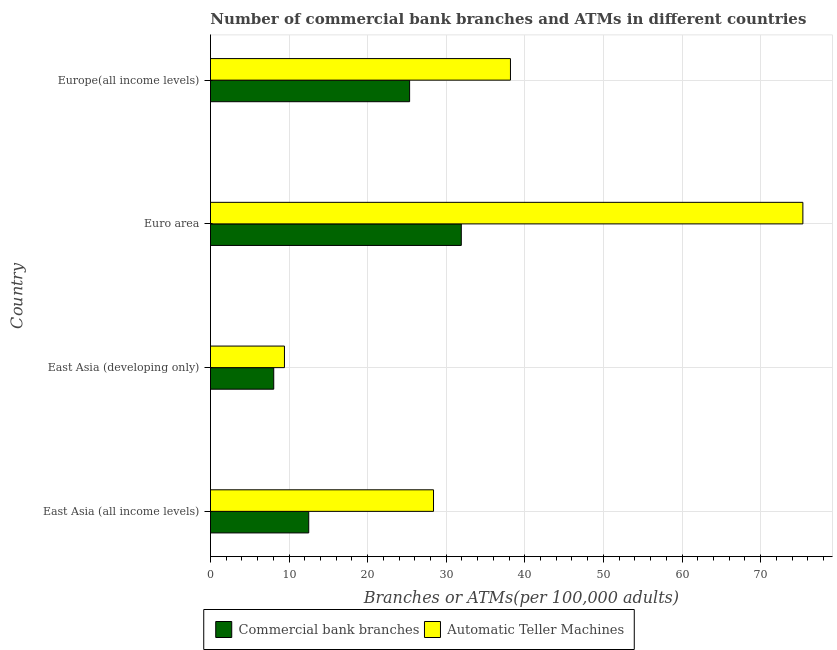Are the number of bars per tick equal to the number of legend labels?
Offer a very short reply. Yes. How many bars are there on the 2nd tick from the top?
Provide a succinct answer. 2. What is the label of the 4th group of bars from the top?
Give a very brief answer. East Asia (all income levels). In how many cases, is the number of bars for a given country not equal to the number of legend labels?
Provide a succinct answer. 0. What is the number of atms in Euro area?
Offer a very short reply. 75.38. Across all countries, what is the maximum number of commercal bank branches?
Provide a short and direct response. 31.92. Across all countries, what is the minimum number of atms?
Provide a short and direct response. 9.41. In which country was the number of commercal bank branches minimum?
Give a very brief answer. East Asia (developing only). What is the total number of commercal bank branches in the graph?
Provide a short and direct response. 77.81. What is the difference between the number of atms in East Asia (all income levels) and that in Euro area?
Provide a succinct answer. -47. What is the difference between the number of commercal bank branches in Europe(all income levels) and the number of atms in East Asia (developing only)?
Offer a very short reply. 15.92. What is the average number of commercal bank branches per country?
Provide a short and direct response. 19.45. What is the difference between the number of commercal bank branches and number of atms in East Asia (all income levels)?
Offer a very short reply. -15.88. What is the ratio of the number of commercal bank branches in East Asia (all income levels) to that in Euro area?
Offer a very short reply. 0.39. Is the difference between the number of atms in East Asia (all income levels) and Europe(all income levels) greater than the difference between the number of commercal bank branches in East Asia (all income levels) and Europe(all income levels)?
Provide a succinct answer. Yes. What is the difference between the highest and the second highest number of atms?
Make the answer very short. 37.21. What is the difference between the highest and the lowest number of atms?
Your answer should be compact. 65.96. Is the sum of the number of atms in East Asia (all income levels) and East Asia (developing only) greater than the maximum number of commercal bank branches across all countries?
Provide a short and direct response. Yes. What does the 2nd bar from the top in East Asia (developing only) represents?
Provide a short and direct response. Commercial bank branches. What does the 1st bar from the bottom in Euro area represents?
Provide a short and direct response. Commercial bank branches. How many bars are there?
Your answer should be very brief. 8. Are all the bars in the graph horizontal?
Ensure brevity in your answer.  Yes. How many countries are there in the graph?
Keep it short and to the point. 4. What is the difference between two consecutive major ticks on the X-axis?
Your answer should be very brief. 10. Where does the legend appear in the graph?
Give a very brief answer. Bottom center. What is the title of the graph?
Your response must be concise. Number of commercial bank branches and ATMs in different countries. Does "Methane" appear as one of the legend labels in the graph?
Keep it short and to the point. No. What is the label or title of the X-axis?
Provide a short and direct response. Branches or ATMs(per 100,0 adults). What is the Branches or ATMs(per 100,000 adults) of Commercial bank branches in East Asia (all income levels)?
Provide a succinct answer. 12.5. What is the Branches or ATMs(per 100,000 adults) in Automatic Teller Machines in East Asia (all income levels)?
Offer a very short reply. 28.38. What is the Branches or ATMs(per 100,000 adults) of Commercial bank branches in East Asia (developing only)?
Your response must be concise. 8.05. What is the Branches or ATMs(per 100,000 adults) in Automatic Teller Machines in East Asia (developing only)?
Keep it short and to the point. 9.41. What is the Branches or ATMs(per 100,000 adults) in Commercial bank branches in Euro area?
Offer a terse response. 31.92. What is the Branches or ATMs(per 100,000 adults) of Automatic Teller Machines in Euro area?
Your answer should be compact. 75.38. What is the Branches or ATMs(per 100,000 adults) of Commercial bank branches in Europe(all income levels)?
Provide a short and direct response. 25.34. What is the Branches or ATMs(per 100,000 adults) of Automatic Teller Machines in Europe(all income levels)?
Ensure brevity in your answer.  38.17. Across all countries, what is the maximum Branches or ATMs(per 100,000 adults) in Commercial bank branches?
Ensure brevity in your answer.  31.92. Across all countries, what is the maximum Branches or ATMs(per 100,000 adults) of Automatic Teller Machines?
Make the answer very short. 75.38. Across all countries, what is the minimum Branches or ATMs(per 100,000 adults) in Commercial bank branches?
Your answer should be very brief. 8.05. Across all countries, what is the minimum Branches or ATMs(per 100,000 adults) of Automatic Teller Machines?
Provide a succinct answer. 9.41. What is the total Branches or ATMs(per 100,000 adults) of Commercial bank branches in the graph?
Offer a very short reply. 77.81. What is the total Branches or ATMs(per 100,000 adults) of Automatic Teller Machines in the graph?
Ensure brevity in your answer.  151.34. What is the difference between the Branches or ATMs(per 100,000 adults) of Commercial bank branches in East Asia (all income levels) and that in East Asia (developing only)?
Provide a short and direct response. 4.45. What is the difference between the Branches or ATMs(per 100,000 adults) of Automatic Teller Machines in East Asia (all income levels) and that in East Asia (developing only)?
Your answer should be very brief. 18.97. What is the difference between the Branches or ATMs(per 100,000 adults) in Commercial bank branches in East Asia (all income levels) and that in Euro area?
Ensure brevity in your answer.  -19.41. What is the difference between the Branches or ATMs(per 100,000 adults) in Automatic Teller Machines in East Asia (all income levels) and that in Euro area?
Your answer should be compact. -47. What is the difference between the Branches or ATMs(per 100,000 adults) in Commercial bank branches in East Asia (all income levels) and that in Europe(all income levels)?
Ensure brevity in your answer.  -12.84. What is the difference between the Branches or ATMs(per 100,000 adults) of Automatic Teller Machines in East Asia (all income levels) and that in Europe(all income levels)?
Offer a very short reply. -9.79. What is the difference between the Branches or ATMs(per 100,000 adults) in Commercial bank branches in East Asia (developing only) and that in Euro area?
Keep it short and to the point. -23.87. What is the difference between the Branches or ATMs(per 100,000 adults) of Automatic Teller Machines in East Asia (developing only) and that in Euro area?
Give a very brief answer. -65.96. What is the difference between the Branches or ATMs(per 100,000 adults) of Commercial bank branches in East Asia (developing only) and that in Europe(all income levels)?
Your answer should be compact. -17.29. What is the difference between the Branches or ATMs(per 100,000 adults) in Automatic Teller Machines in East Asia (developing only) and that in Europe(all income levels)?
Provide a succinct answer. -28.76. What is the difference between the Branches or ATMs(per 100,000 adults) in Commercial bank branches in Euro area and that in Europe(all income levels)?
Ensure brevity in your answer.  6.58. What is the difference between the Branches or ATMs(per 100,000 adults) of Automatic Teller Machines in Euro area and that in Europe(all income levels)?
Provide a short and direct response. 37.21. What is the difference between the Branches or ATMs(per 100,000 adults) of Commercial bank branches in East Asia (all income levels) and the Branches or ATMs(per 100,000 adults) of Automatic Teller Machines in East Asia (developing only)?
Make the answer very short. 3.09. What is the difference between the Branches or ATMs(per 100,000 adults) in Commercial bank branches in East Asia (all income levels) and the Branches or ATMs(per 100,000 adults) in Automatic Teller Machines in Euro area?
Give a very brief answer. -62.88. What is the difference between the Branches or ATMs(per 100,000 adults) in Commercial bank branches in East Asia (all income levels) and the Branches or ATMs(per 100,000 adults) in Automatic Teller Machines in Europe(all income levels)?
Offer a very short reply. -25.67. What is the difference between the Branches or ATMs(per 100,000 adults) of Commercial bank branches in East Asia (developing only) and the Branches or ATMs(per 100,000 adults) of Automatic Teller Machines in Euro area?
Provide a short and direct response. -67.33. What is the difference between the Branches or ATMs(per 100,000 adults) in Commercial bank branches in East Asia (developing only) and the Branches or ATMs(per 100,000 adults) in Automatic Teller Machines in Europe(all income levels)?
Your answer should be very brief. -30.12. What is the difference between the Branches or ATMs(per 100,000 adults) of Commercial bank branches in Euro area and the Branches or ATMs(per 100,000 adults) of Automatic Teller Machines in Europe(all income levels)?
Offer a very short reply. -6.25. What is the average Branches or ATMs(per 100,000 adults) of Commercial bank branches per country?
Offer a very short reply. 19.45. What is the average Branches or ATMs(per 100,000 adults) of Automatic Teller Machines per country?
Your answer should be compact. 37.84. What is the difference between the Branches or ATMs(per 100,000 adults) of Commercial bank branches and Branches or ATMs(per 100,000 adults) of Automatic Teller Machines in East Asia (all income levels)?
Offer a terse response. -15.88. What is the difference between the Branches or ATMs(per 100,000 adults) of Commercial bank branches and Branches or ATMs(per 100,000 adults) of Automatic Teller Machines in East Asia (developing only)?
Provide a short and direct response. -1.36. What is the difference between the Branches or ATMs(per 100,000 adults) in Commercial bank branches and Branches or ATMs(per 100,000 adults) in Automatic Teller Machines in Euro area?
Your response must be concise. -43.46. What is the difference between the Branches or ATMs(per 100,000 adults) in Commercial bank branches and Branches or ATMs(per 100,000 adults) in Automatic Teller Machines in Europe(all income levels)?
Offer a terse response. -12.83. What is the ratio of the Branches or ATMs(per 100,000 adults) in Commercial bank branches in East Asia (all income levels) to that in East Asia (developing only)?
Your answer should be very brief. 1.55. What is the ratio of the Branches or ATMs(per 100,000 adults) in Automatic Teller Machines in East Asia (all income levels) to that in East Asia (developing only)?
Ensure brevity in your answer.  3.01. What is the ratio of the Branches or ATMs(per 100,000 adults) in Commercial bank branches in East Asia (all income levels) to that in Euro area?
Provide a short and direct response. 0.39. What is the ratio of the Branches or ATMs(per 100,000 adults) of Automatic Teller Machines in East Asia (all income levels) to that in Euro area?
Offer a terse response. 0.38. What is the ratio of the Branches or ATMs(per 100,000 adults) in Commercial bank branches in East Asia (all income levels) to that in Europe(all income levels)?
Ensure brevity in your answer.  0.49. What is the ratio of the Branches or ATMs(per 100,000 adults) of Automatic Teller Machines in East Asia (all income levels) to that in Europe(all income levels)?
Offer a terse response. 0.74. What is the ratio of the Branches or ATMs(per 100,000 adults) of Commercial bank branches in East Asia (developing only) to that in Euro area?
Give a very brief answer. 0.25. What is the ratio of the Branches or ATMs(per 100,000 adults) of Automatic Teller Machines in East Asia (developing only) to that in Euro area?
Your answer should be compact. 0.12. What is the ratio of the Branches or ATMs(per 100,000 adults) of Commercial bank branches in East Asia (developing only) to that in Europe(all income levels)?
Your answer should be compact. 0.32. What is the ratio of the Branches or ATMs(per 100,000 adults) of Automatic Teller Machines in East Asia (developing only) to that in Europe(all income levels)?
Offer a very short reply. 0.25. What is the ratio of the Branches or ATMs(per 100,000 adults) of Commercial bank branches in Euro area to that in Europe(all income levels)?
Keep it short and to the point. 1.26. What is the ratio of the Branches or ATMs(per 100,000 adults) in Automatic Teller Machines in Euro area to that in Europe(all income levels)?
Ensure brevity in your answer.  1.97. What is the difference between the highest and the second highest Branches or ATMs(per 100,000 adults) in Commercial bank branches?
Keep it short and to the point. 6.58. What is the difference between the highest and the second highest Branches or ATMs(per 100,000 adults) of Automatic Teller Machines?
Offer a terse response. 37.21. What is the difference between the highest and the lowest Branches or ATMs(per 100,000 adults) of Commercial bank branches?
Offer a terse response. 23.87. What is the difference between the highest and the lowest Branches or ATMs(per 100,000 adults) in Automatic Teller Machines?
Provide a succinct answer. 65.96. 